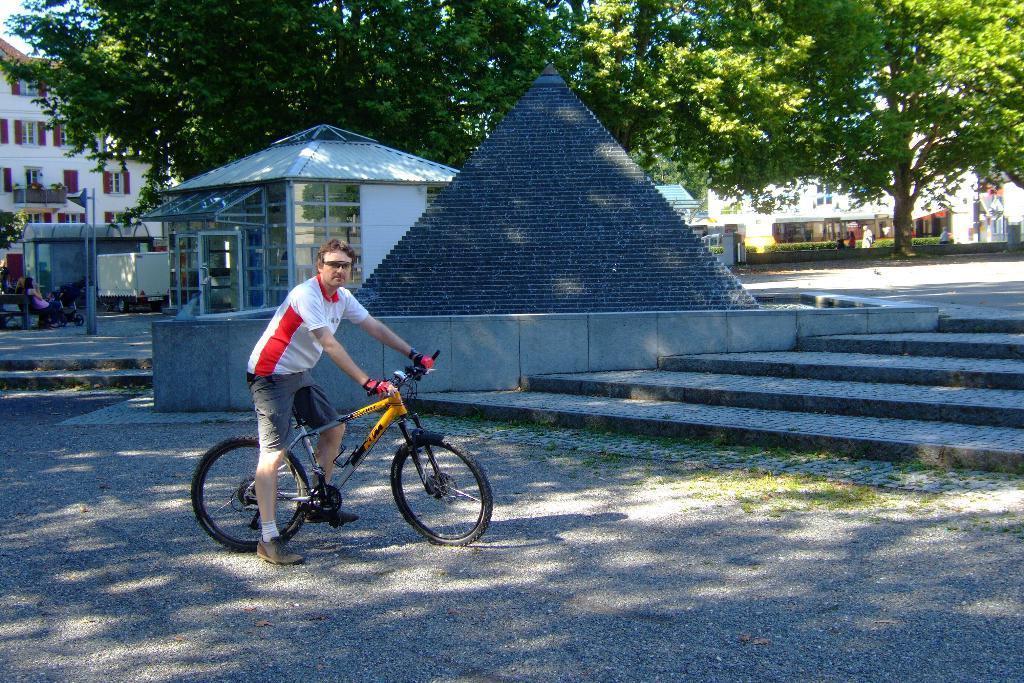Describe this image in one or two sentences. In the center of the image a man is sitting on a bicycle. In the middle of the image a pyramid is there. On the left side of the image we can see the buildings, pole, truck, bench, a person and a wheel chair are present. On the right side of the image trees are there. In the middle of the image stairs are present. At the bottom of the image ground is there. At the top of the image sky is present. 